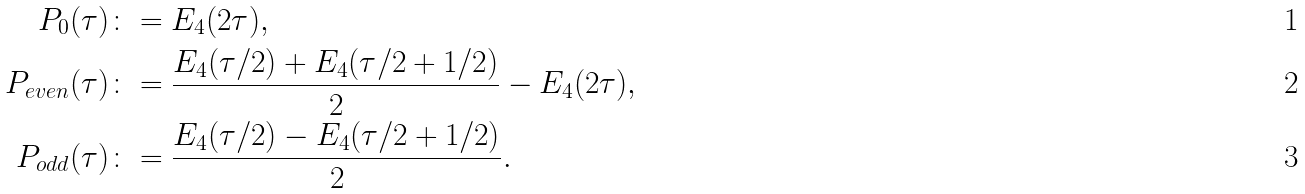<formula> <loc_0><loc_0><loc_500><loc_500>P _ { 0 } ( \tau ) & \colon = E _ { 4 } ( 2 \tau ) , \\ P _ { e v e n } ( \tau ) & \colon = \frac { E _ { 4 } ( \tau / 2 ) + E _ { 4 } ( \tau / 2 + 1 / 2 ) } { 2 } - E _ { 4 } ( 2 \tau ) , \\ P _ { o d d } ( \tau ) & \colon = \frac { E _ { 4 } ( \tau / 2 ) - E _ { 4 } ( \tau / 2 + 1 / 2 ) } { 2 } .</formula> 